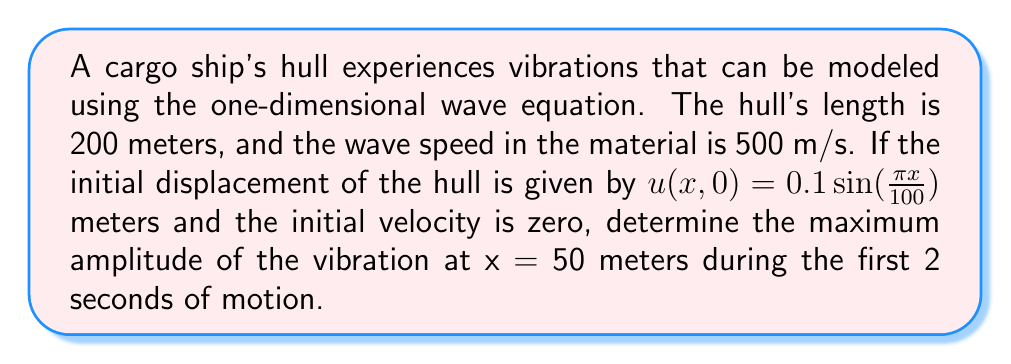Can you answer this question? To solve this problem, we'll use the solution to the one-dimensional wave equation with fixed ends:

1) The general solution for the wave equation is:
   $$u(x,t) = \sum_{n=1}^{\infty} [A_n \cos(\omega_n t) + B_n \sin(\omega_n t)] \sin(\frac{n\pi x}{L})$$

2) Given conditions:
   - Length (L) = 200 m
   - Wave speed (c) = 500 m/s
   - Initial displacement: $u(x,0) = 0.1 \sin(\frac{\pi x}{100})$
   - Initial velocity: $u_t(x,0) = 0$

3) From the initial displacement, we can see that only the first mode (n=1) is excited:
   $A_1 = 0.1$, and all other $A_n = 0$

4) Since the initial velocity is zero, all $B_n = 0$

5) The angular frequency for n=1 is:
   $$\omega_1 = \frac{c\pi}{L} = \frac{500\pi}{200} = \frac{5\pi}{2} \text{ rad/s}$$

6) Therefore, the solution reduces to:
   $$u(x,t) = 0.1 \cos(\frac{5\pi}{2}t) \sin(\frac{\pi x}{100})$$

7) At x = 50 m:
   $$u(50,t) = 0.1 \cos(\frac{5\pi}{2}t) \sin(\frac{\pi}{2}) = 0.1 \cos(\frac{5\pi}{2}t)$$

8) The maximum amplitude over time is the coefficient: 0.1 meters
Answer: 0.1 meters 